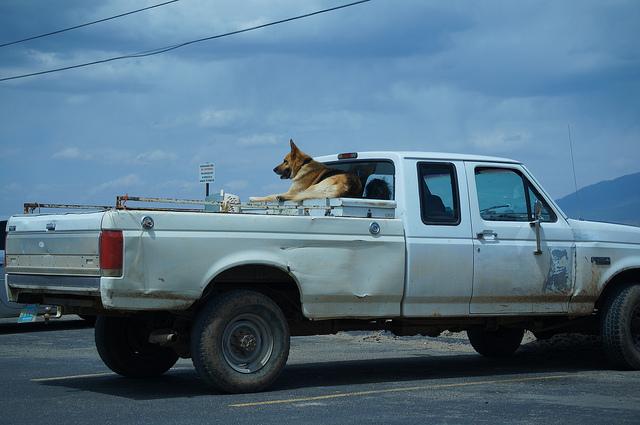What is on the very end of the truck?
Answer briefly. Dog. What color is the truck?
Quick response, please. White. What is on top of the truck?
Concise answer only. Dog. Is this safe for the dog?
Give a very brief answer. No. What type of dog is this?
Quick response, please. German shepherd. Where is the driver?
Write a very short answer. In truck. Where is the dog sitting?
Answer briefly. On toolbox. Where are the dents?
Be succinct. Back. What is the dog doing?
Write a very short answer. Laying down. What color is the dog?
Quick response, please. Brown. 